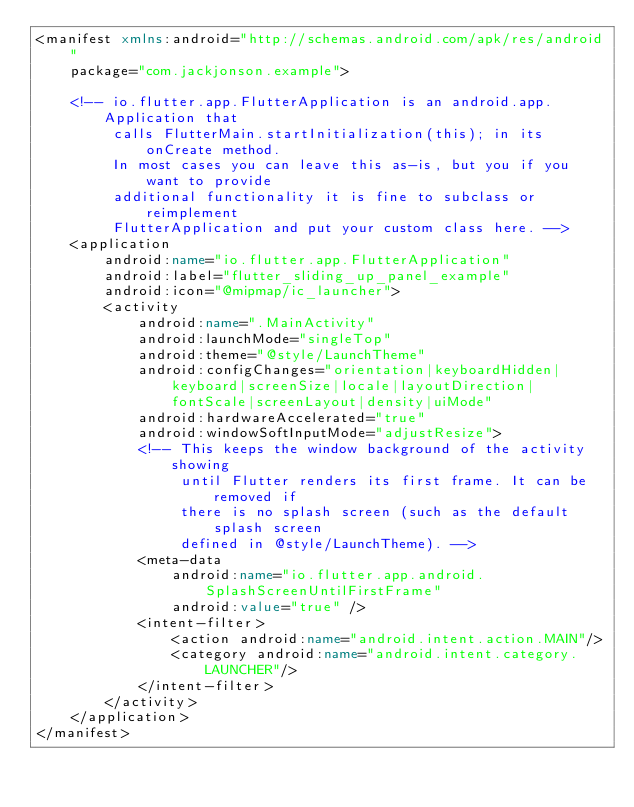<code> <loc_0><loc_0><loc_500><loc_500><_XML_><manifest xmlns:android="http://schemas.android.com/apk/res/android"
    package="com.jackjonson.example">

    <!-- io.flutter.app.FlutterApplication is an android.app.Application that
         calls FlutterMain.startInitialization(this); in its onCreate method.
         In most cases you can leave this as-is, but you if you want to provide
         additional functionality it is fine to subclass or reimplement
         FlutterApplication and put your custom class here. -->
    <application
        android:name="io.flutter.app.FlutterApplication"
        android:label="flutter_sliding_up_panel_example"
        android:icon="@mipmap/ic_launcher">
        <activity
            android:name=".MainActivity"
            android:launchMode="singleTop"
            android:theme="@style/LaunchTheme"
            android:configChanges="orientation|keyboardHidden|keyboard|screenSize|locale|layoutDirection|fontScale|screenLayout|density|uiMode"
            android:hardwareAccelerated="true"
            android:windowSoftInputMode="adjustResize">
            <!-- This keeps the window background of the activity showing
                 until Flutter renders its first frame. It can be removed if
                 there is no splash screen (such as the default splash screen
                 defined in @style/LaunchTheme). -->
            <meta-data
                android:name="io.flutter.app.android.SplashScreenUntilFirstFrame"
                android:value="true" />
            <intent-filter>
                <action android:name="android.intent.action.MAIN"/>
                <category android:name="android.intent.category.LAUNCHER"/>
            </intent-filter>
        </activity>
    </application>
</manifest>
</code> 